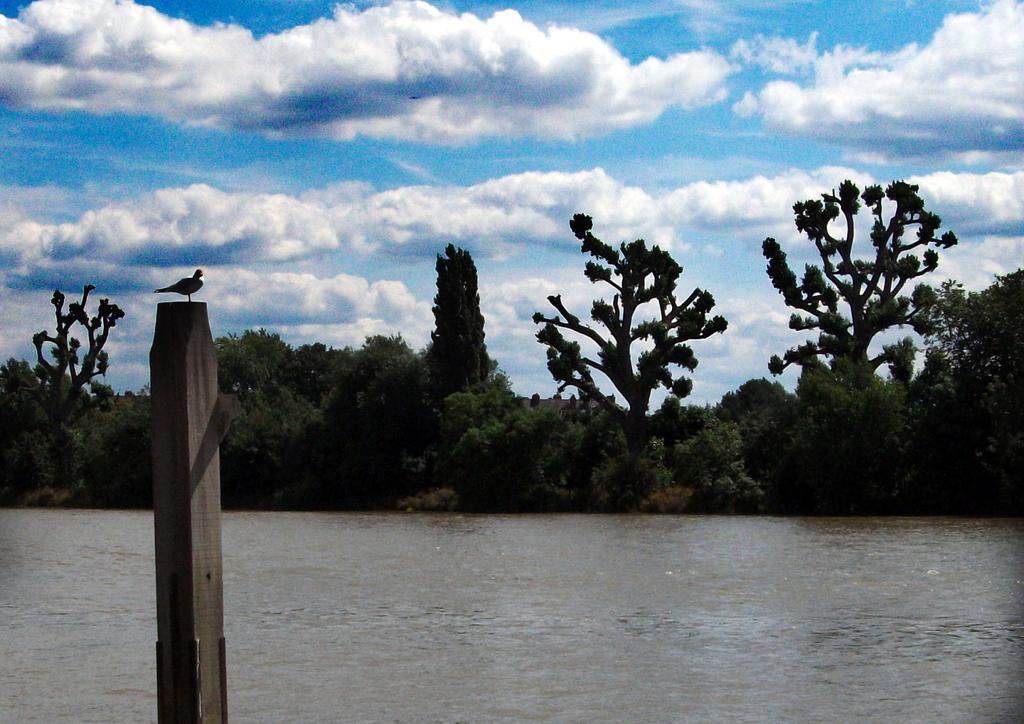Could you give a brief overview of what you see in this image? In this image I can see the bird on the wooden pole. In the background I can see the water, few trees and the sky is in blue and white color. 